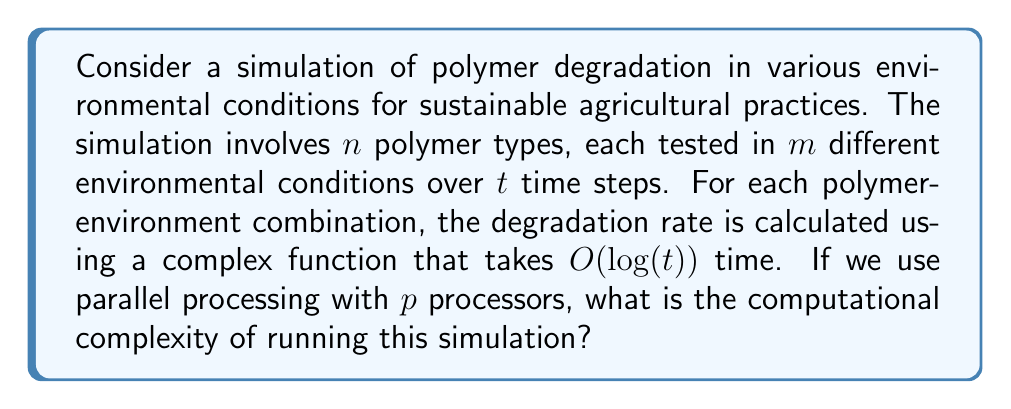Teach me how to tackle this problem. Let's break down the problem and analyze it step by step:

1. We have $n$ polymer types and $m$ environmental conditions, resulting in $n \times m$ combinations.

2. Each combination is simulated over $t$ time steps.

3. For each time step of each combination, we calculate the degradation rate, which takes $O(log(t))$ time.

4. The total number of calculations is thus:
   $n \times m \times t \times O(log(t))$

5. Without parallel processing, the time complexity would be:
   $O(nmt \cdot log(t))$

6. However, we have $p$ processors working in parallel. Assuming perfect load balancing, we can divide the total work by the number of processors:

   $\frac{O(nmt \cdot log(t))}{p}$

7. The overall time complexity with parallel processing is therefore:
   $O(\frac{nmt \cdot log(t)}{p})$

It's important to note that this complexity assumes that the number of processors $p$ is less than or equal to the total number of calculations $(n \times m \times t)$. If $p$ were larger, we wouldn't be able to utilize all processors effectively, and the complexity would remain $O(log(t))$, which is the time for a single calculation.
Answer: The computational complexity of the polymer degradation simulation with parallel processing is $O(\frac{nmt \cdot log(t)}{p})$, where $n$ is the number of polymer types, $m$ is the number of environmental conditions, $t$ is the number of time steps, and $p$ is the number of processors. 